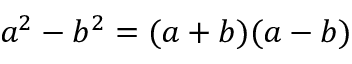Convert formula to latex. <formula><loc_0><loc_0><loc_500><loc_500>a ^ { 2 } - b ^ { 2 } = ( a + b ) ( a - b )</formula> 